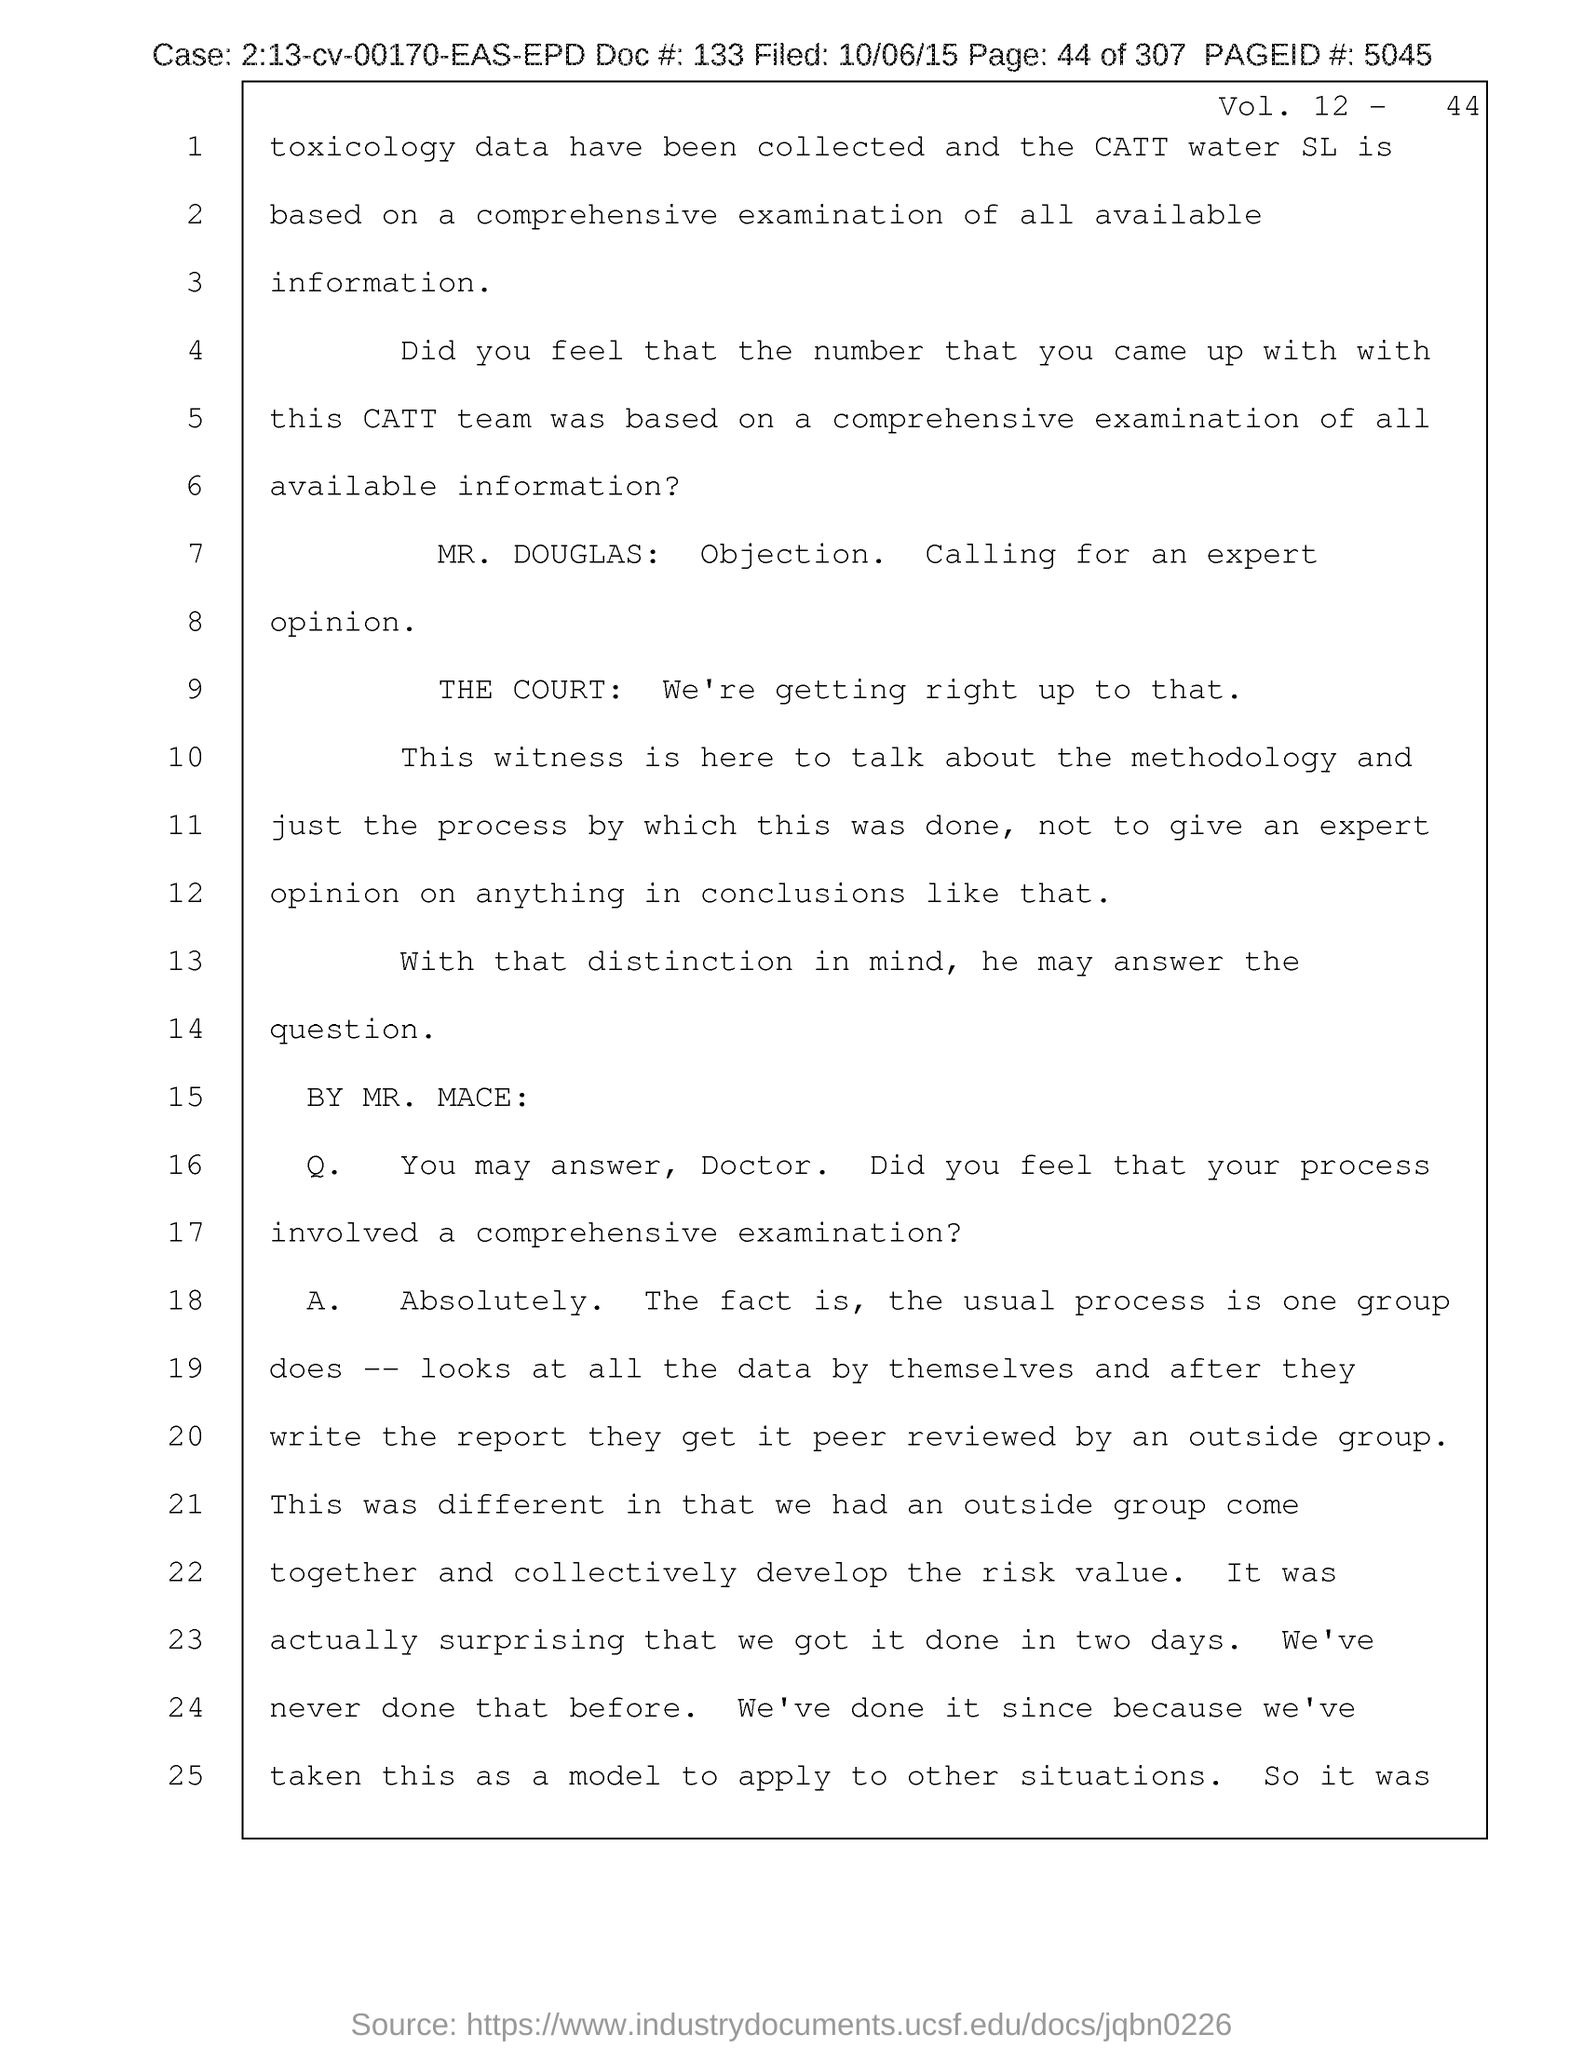What is the Page ID # mentioned in the document?
Ensure brevity in your answer.  5045. What is the Vol. no. given in the document?
Give a very brief answer. 12. What is the page no mentioned in this document?
Offer a very short reply. 44 of 307. What is the case no mentioned in the document?
Offer a terse response. 2:13-cv-00170-EAS-EPD. What is the doc # given in the document?
Offer a terse response. 133. What is the filed date of the document?
Your response must be concise. 10/06/15. 